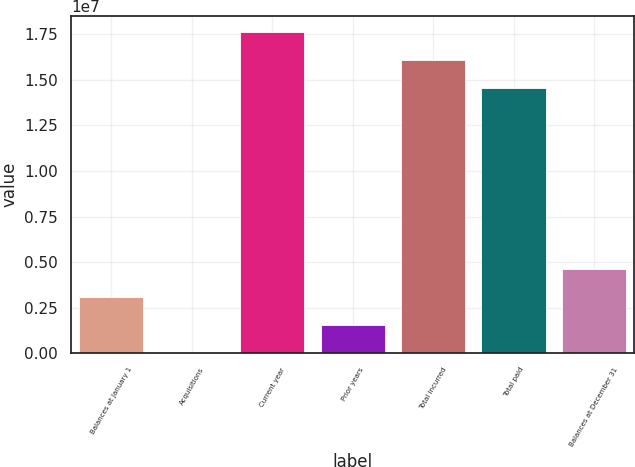Convert chart to OTSL. <chart><loc_0><loc_0><loc_500><loc_500><bar_chart><fcel>Balances at January 1<fcel>Acquisitions<fcel>Current year<fcel>Prior years<fcel>Total incurred<fcel>Total paid<fcel>Balances at December 31<nl><fcel>3.09193e+06<fcel>21198<fcel>1.76428e+07<fcel>1.55656e+06<fcel>1.61074e+07<fcel>1.4572e+07<fcel>4.6273e+06<nl></chart> 